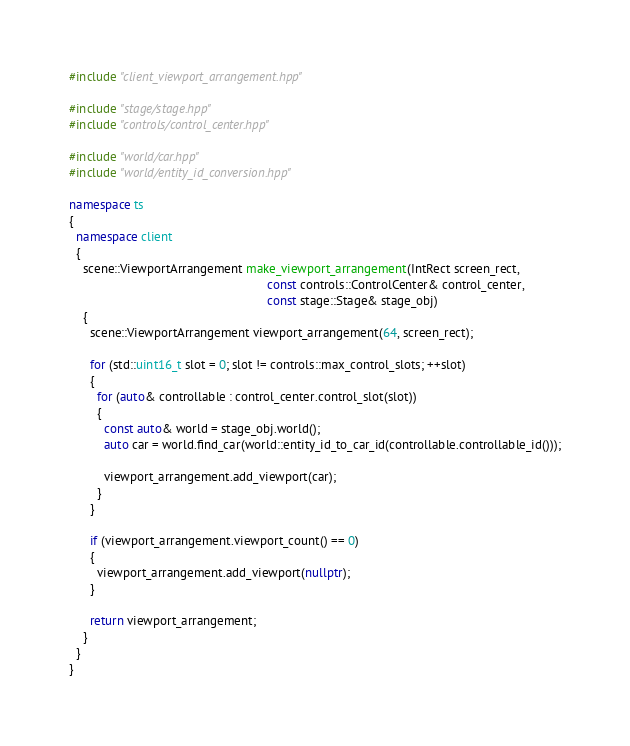Convert code to text. <code><loc_0><loc_0><loc_500><loc_500><_C++_>#include "client_viewport_arrangement.hpp"

#include "stage/stage.hpp"
#include "controls/control_center.hpp"

#include "world/car.hpp"
#include "world/entity_id_conversion.hpp"

namespace ts
{
  namespace client
  {
    scene::ViewportArrangement make_viewport_arrangement(IntRect screen_rect,
                                                         const controls::ControlCenter& control_center,
                                                         const stage::Stage& stage_obj)
    {
      scene::ViewportArrangement viewport_arrangement(64, screen_rect);

      for (std::uint16_t slot = 0; slot != controls::max_control_slots; ++slot)
      {
        for (auto& controllable : control_center.control_slot(slot))
        {
          const auto& world = stage_obj.world();
          auto car = world.find_car(world::entity_id_to_car_id(controllable.controllable_id()));

          viewport_arrangement.add_viewport(car);
        }
      }

      if (viewport_arrangement.viewport_count() == 0)
      {
        viewport_arrangement.add_viewport(nullptr);
      }

      return viewport_arrangement;
    }
  }
}</code> 